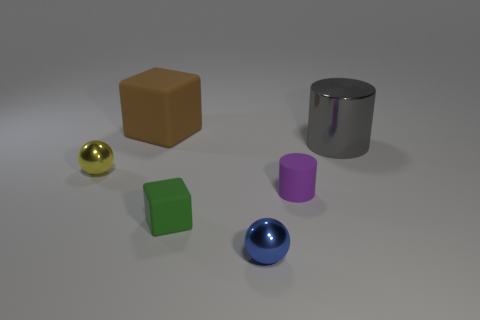Do the objects in the image indicate any specific use or purpose? The objects don't distinctly indicate a particular use or purpose. They resemble geometric shapes typically found in a set for educational purposes, perhaps used to teach about colors, shapes, and materials. 